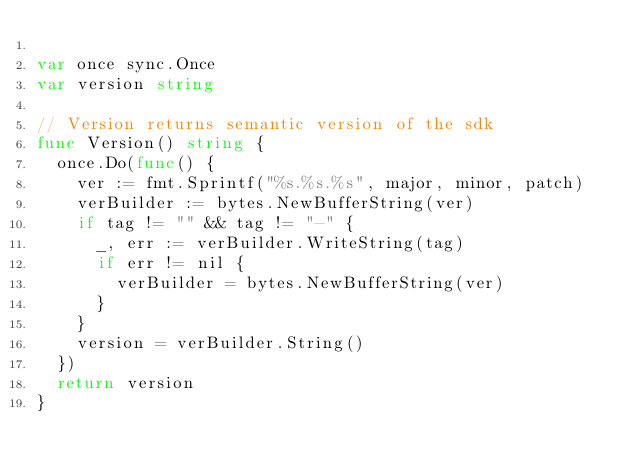<code> <loc_0><loc_0><loc_500><loc_500><_Go_>
var once sync.Once
var version string

// Version returns semantic version of the sdk
func Version() string {
	once.Do(func() {
		ver := fmt.Sprintf("%s.%s.%s", major, minor, patch)
		verBuilder := bytes.NewBufferString(ver)
		if tag != "" && tag != "-" {
			_, err := verBuilder.WriteString(tag)
			if err != nil {
				verBuilder = bytes.NewBufferString(ver)
			}
		}
		version = verBuilder.String()
	})
	return version
}
</code> 